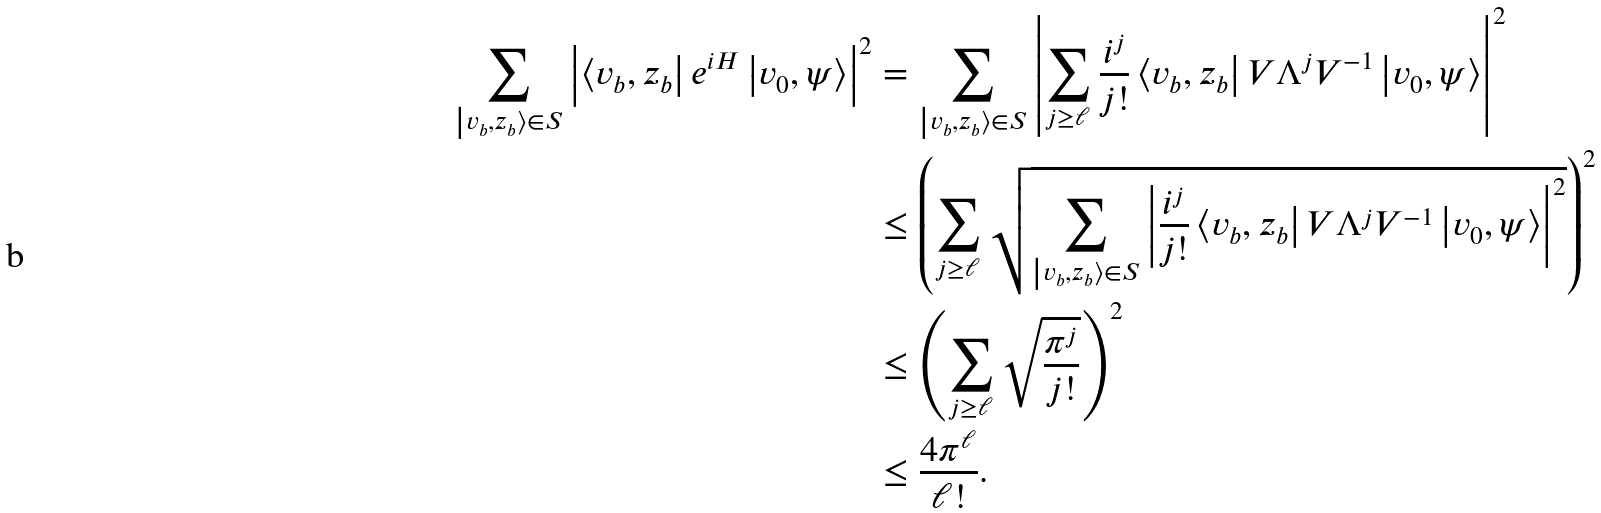Convert formula to latex. <formula><loc_0><loc_0><loc_500><loc_500>\sum _ { \left | v _ { b } , z _ { b } \right \rangle \in S } \left | \left \langle v _ { b } , z _ { b } \right | e ^ { i H } \left | v _ { 0 } , \psi \right \rangle \right | ^ { 2 } & = \sum _ { \left | v _ { b } , z _ { b } \right \rangle \in S } \left | \sum _ { j \geq \ell } \frac { i ^ { j } } { j ! } \left \langle v _ { b } , z _ { b } \right | V \Lambda ^ { j } V ^ { - 1 } \left | v _ { 0 } , \psi \right \rangle \right | ^ { 2 } \\ & \leq \left ( \sum _ { j \geq \ell } \sqrt { \sum _ { \left | v _ { b } , z _ { b } \right \rangle \in S } \left | \frac { i ^ { j } } { j ! } \left \langle v _ { b } , z _ { b } \right | V \Lambda ^ { j } V ^ { - 1 } \left | v _ { 0 } , \psi \right \rangle \right | ^ { 2 } } \right ) ^ { 2 } \\ & \leq \left ( \sum _ { j \geq \ell } \sqrt { \frac { \pi ^ { j } } { j ! } } \right ) ^ { 2 } \\ & \leq \frac { 4 \pi ^ { \ell } } { \ell ! } .</formula> 